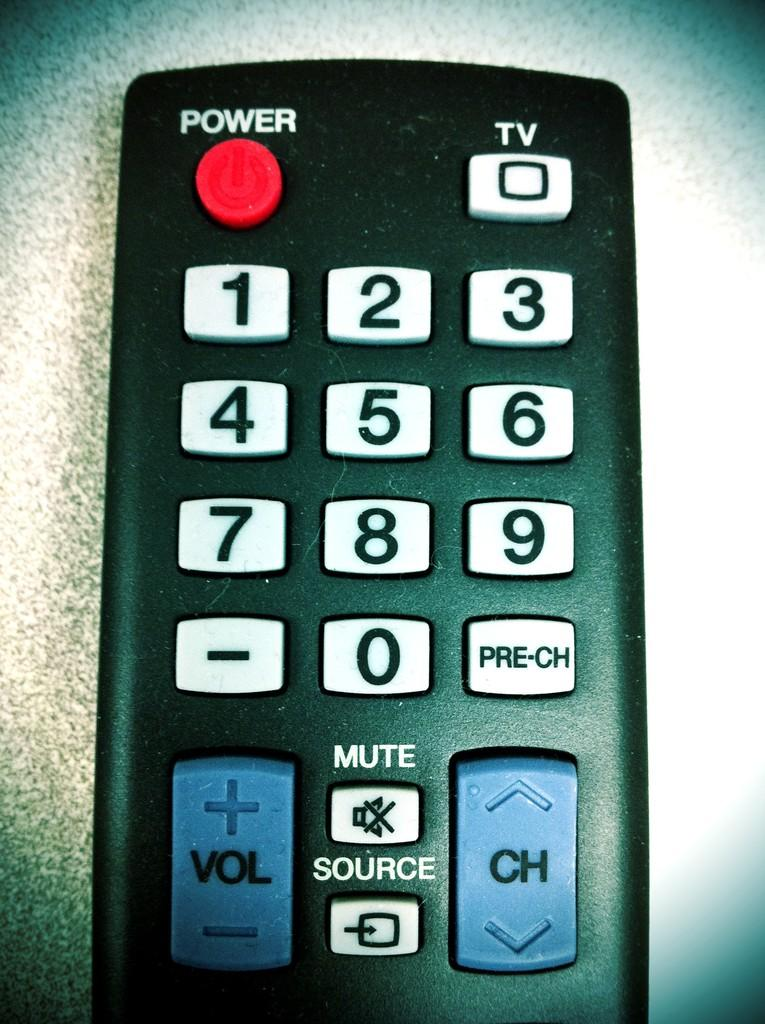<image>
Describe the image concisely. Among the buttons on this TV remote are Power and TV. 